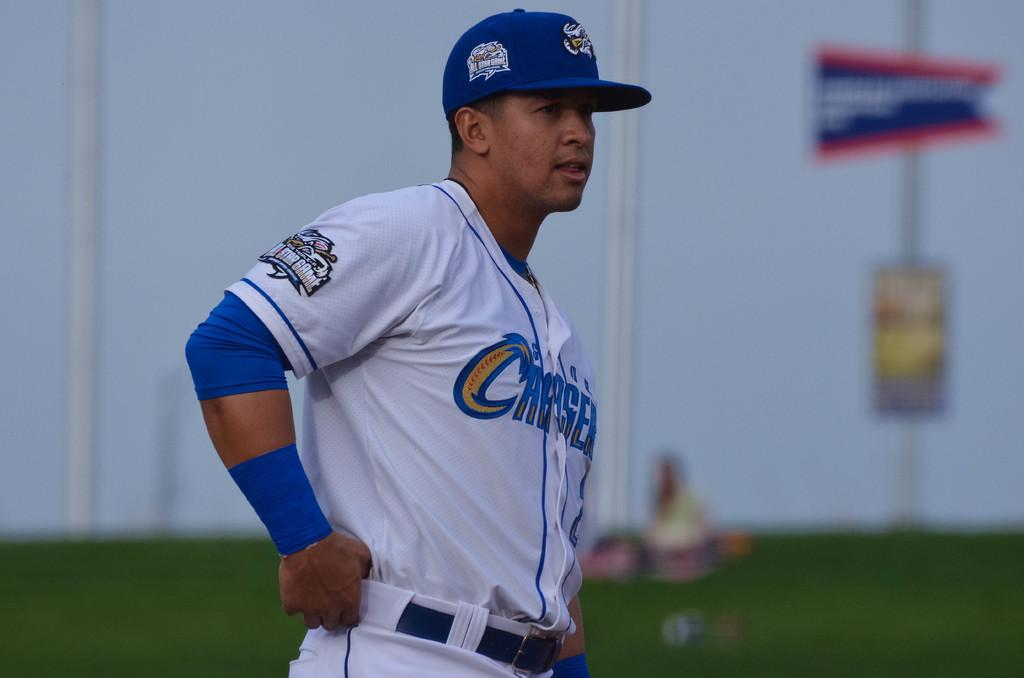What is the main subject in the image? There is a person standing in the image. Can you describe the background of the image? The background of the image is blurred. What type of rake is being used to harvest crops in the image? There is no rake or any indication of crop harvesting in the image. What causes the bulb to emit light in the image? There is no bulb or any source of light in the image. What is the cause of the thunder in the image? There is no thunder or any weather-related elements in the image. 